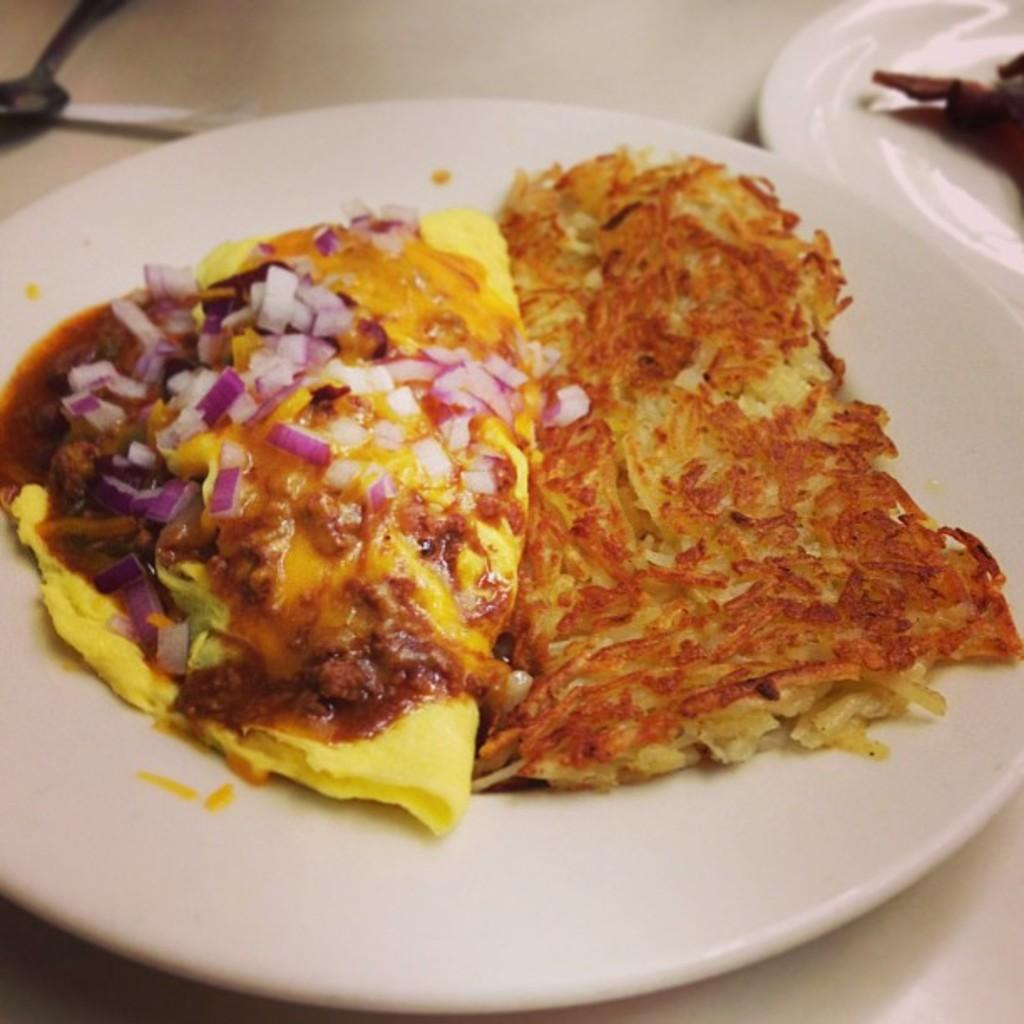What is placed on the table in the image? There are two plates with food items arranged on them. What is the purpose of the spoon in the image? The spoon is in front of the plates, likely for eating the food. Can you describe the arrangement of the food items on the plates? The provided facts do not specify the arrangement of the food items on the plates. How many wings are visible on the plate in the image? There is no mention of wings in the image; only food items on two plates are described. 